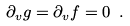Convert formula to latex. <formula><loc_0><loc_0><loc_500><loc_500>\partial _ { v } g = \partial _ { v } f = 0 \text { } .</formula> 